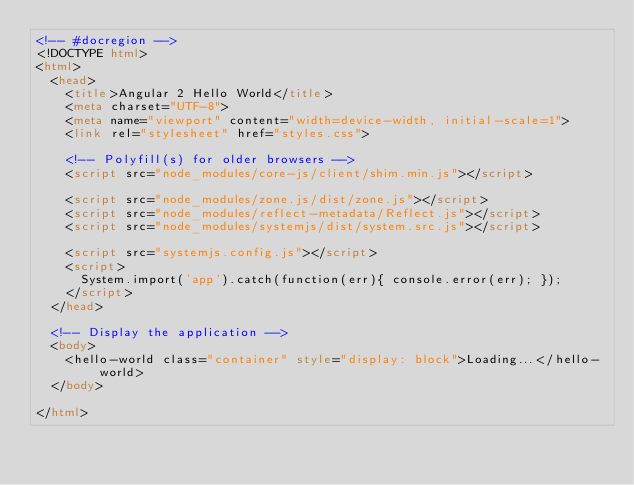Convert code to text. <code><loc_0><loc_0><loc_500><loc_500><_HTML_><!-- #docregion -->
<!DOCTYPE html>
<html>
  <head>
    <title>Angular 2 Hello World</title>
    <meta charset="UTF-8">
    <meta name="viewport" content="width=device-width, initial-scale=1">
    <link rel="stylesheet" href="styles.css">

    <!-- Polyfill(s) for older browsers -->
    <script src="node_modules/core-js/client/shim.min.js"></script>

    <script src="node_modules/zone.js/dist/zone.js"></script>
    <script src="node_modules/reflect-metadata/Reflect.js"></script>
    <script src="node_modules/systemjs/dist/system.src.js"></script>

    <script src="systemjs.config.js"></script>
    <script>
      System.import('app').catch(function(err){ console.error(err); });
    </script>
  </head>

  <!-- Display the application -->
  <body>
    <hello-world class="container" style="display: block">Loading...</hello-world>
  </body>

</html>
</code> 